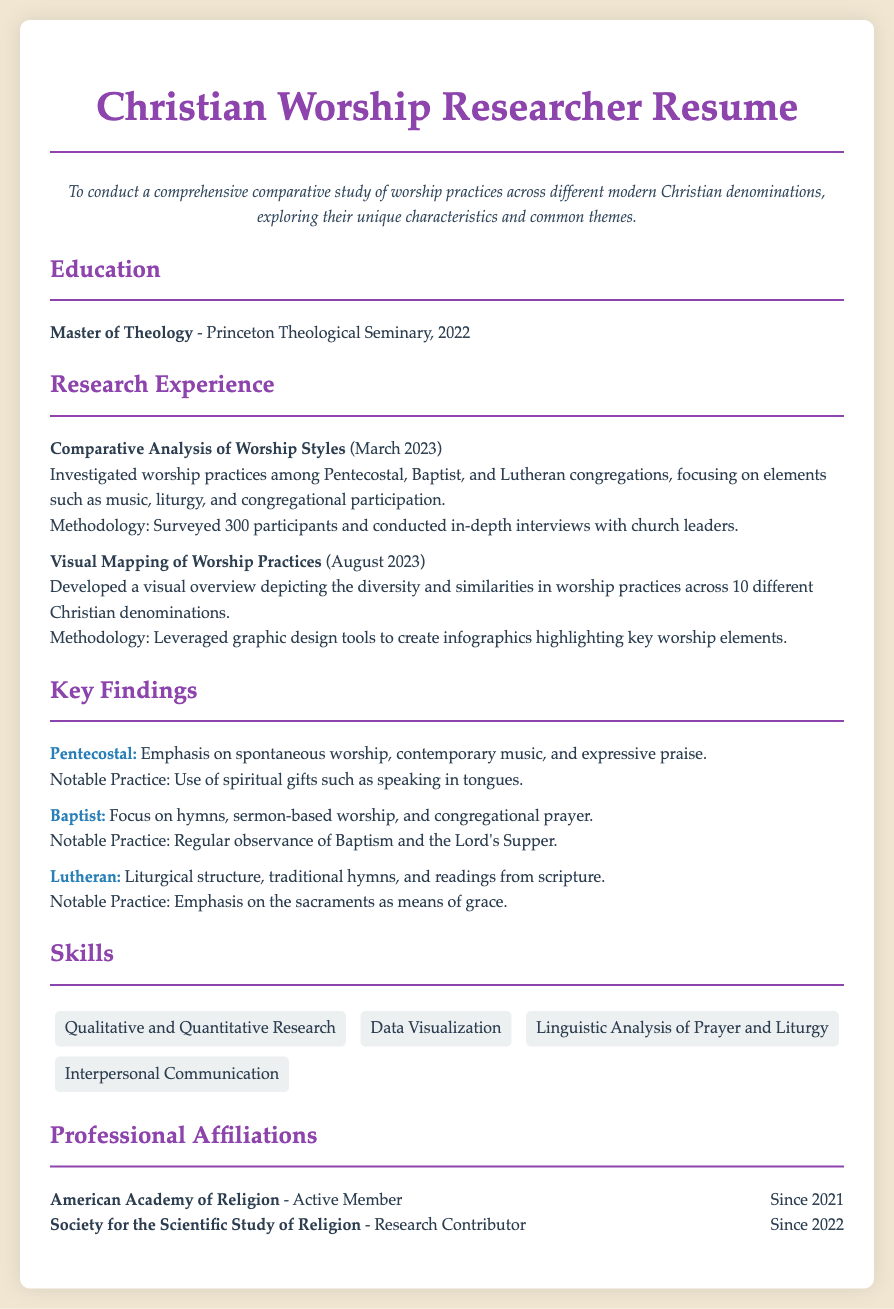What is the degree obtained? The document states that the individual holds a Master of Theology.
Answer: Master of Theology Which university awarded the degree? The degree was awarded by Princeton Theological Seminary.
Answer: Princeton Theological Seminary In what year was the degree received? The year of degree completion mentioned in the document is 2022.
Answer: 2022 What is the focus of the first research experience? The first research experience focused on worship practices among Pentecostal, Baptist, and Lutheran congregations.
Answer: Worship practices among Pentecostal, Baptist, and Lutheran congregations How many participants were surveyed in the research? The document states that 300 participants were surveyed during the research.
Answer: 300 Which denomination emphasizes spontaneous worship? The document indicates that Pentecostal practices involve an emphasis on spontaneous worship.
Answer: Pentecostal What notable practice is highlighted for Baptists? The notable practice for Baptists mentioned is regular observance of Baptism and the Lord's Supper.
Answer: Regular observance of Baptism and the Lord's Supper What type of skills are highlighted in the skills section? The document outlines skills such as Qualitative and Quantitative Research and Data Visualization, among others.
Answer: Qualitative and Quantitative Research, Data Visualization What is one of the affiliations listed? The document lists the American Academy of Religion as one of the affiliations of the individual.
Answer: American Academy of Religion 